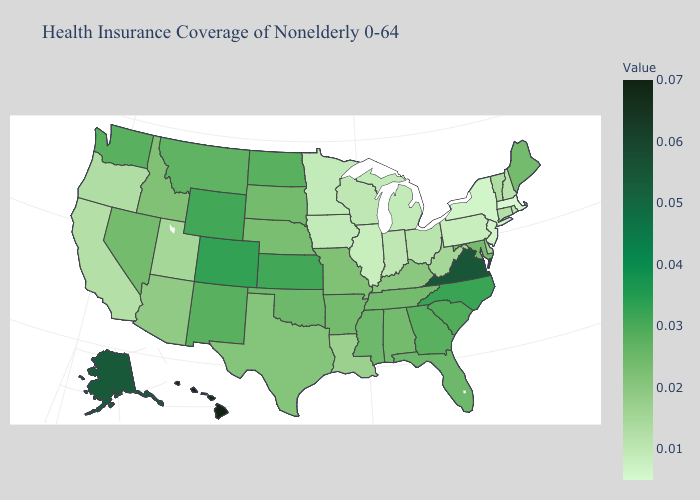Which states have the lowest value in the USA?
Keep it brief. Massachusetts. Does Massachusetts have the lowest value in the USA?
Answer briefly. Yes. Among the states that border Delaware , does Maryland have the highest value?
Short answer required. Yes. 